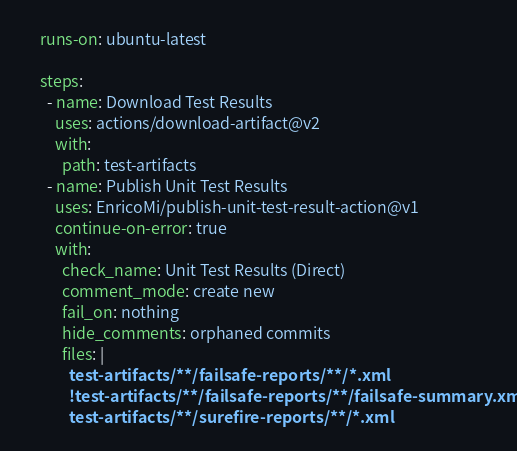Convert code to text. <code><loc_0><loc_0><loc_500><loc_500><_YAML_>    runs-on: ubuntu-latest

    steps:
      - name: Download Test Results
        uses: actions/download-artifact@v2
        with:
          path: test-artifacts
      - name: Publish Unit Test Results
        uses: EnricoMi/publish-unit-test-result-action@v1
        continue-on-error: true
        with:
          check_name: Unit Test Results (Direct)
          comment_mode: create new
          fail_on: nothing
          hide_comments: orphaned commits
          files: |
            test-artifacts/**/failsafe-reports/**/*.xml
            !test-artifacts/**/failsafe-reports/**/failsafe-summary.xml
            test-artifacts/**/surefire-reports/**/*.xml
</code> 